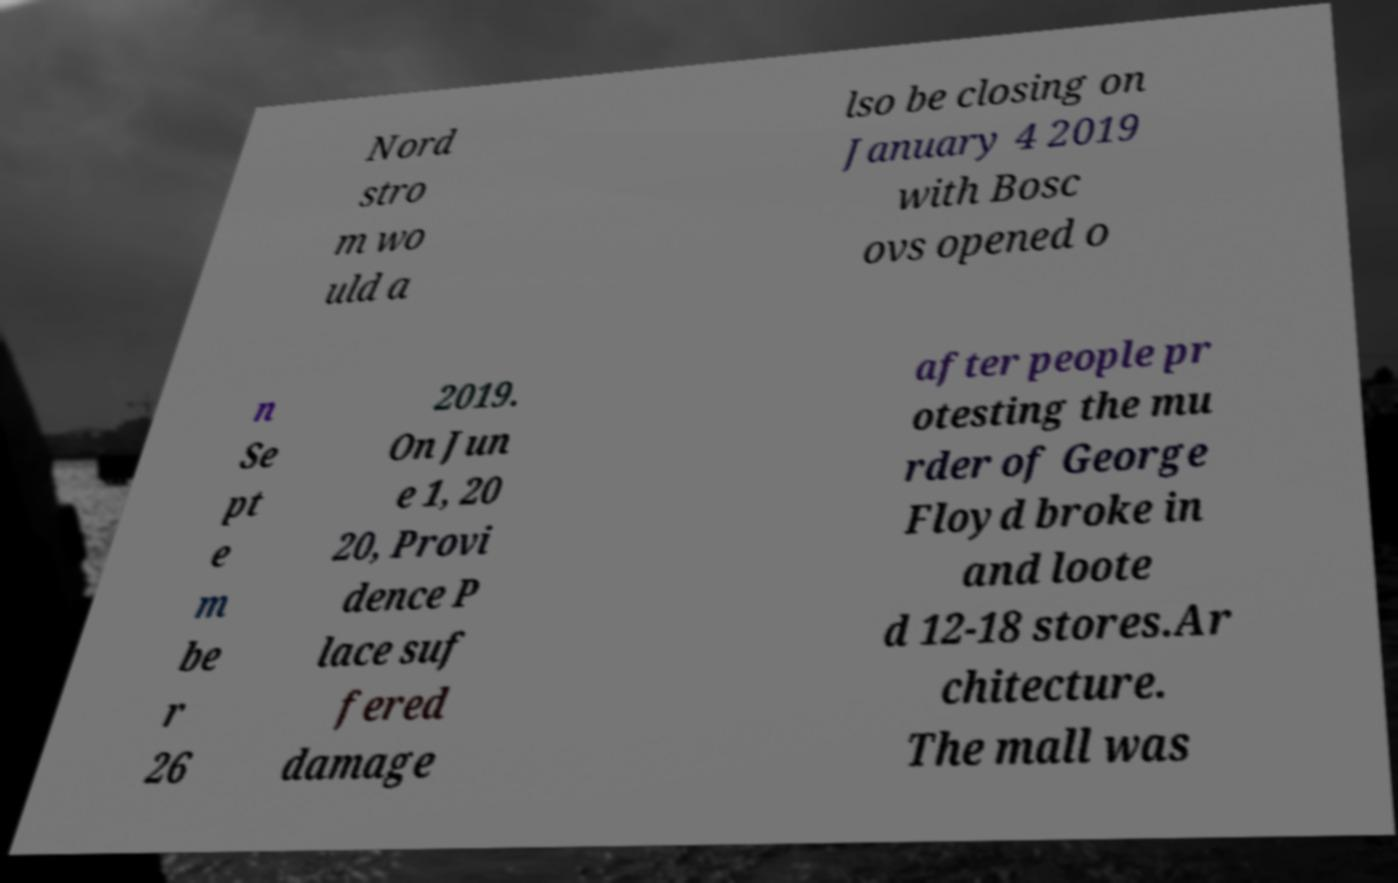Please identify and transcribe the text found in this image. Nord stro m wo uld a lso be closing on January 4 2019 with Bosc ovs opened o n Se pt e m be r 26 2019. On Jun e 1, 20 20, Provi dence P lace suf fered damage after people pr otesting the mu rder of George Floyd broke in and loote d 12-18 stores.Ar chitecture. The mall was 